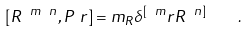Convert formula to latex. <formula><loc_0><loc_0><loc_500><loc_500>[ R ^ { \ m \ n } , P _ { \ } r ] = m _ { R } \delta ^ { [ \ m } _ { \ } r R ^ { \ n ] } \quad .</formula> 